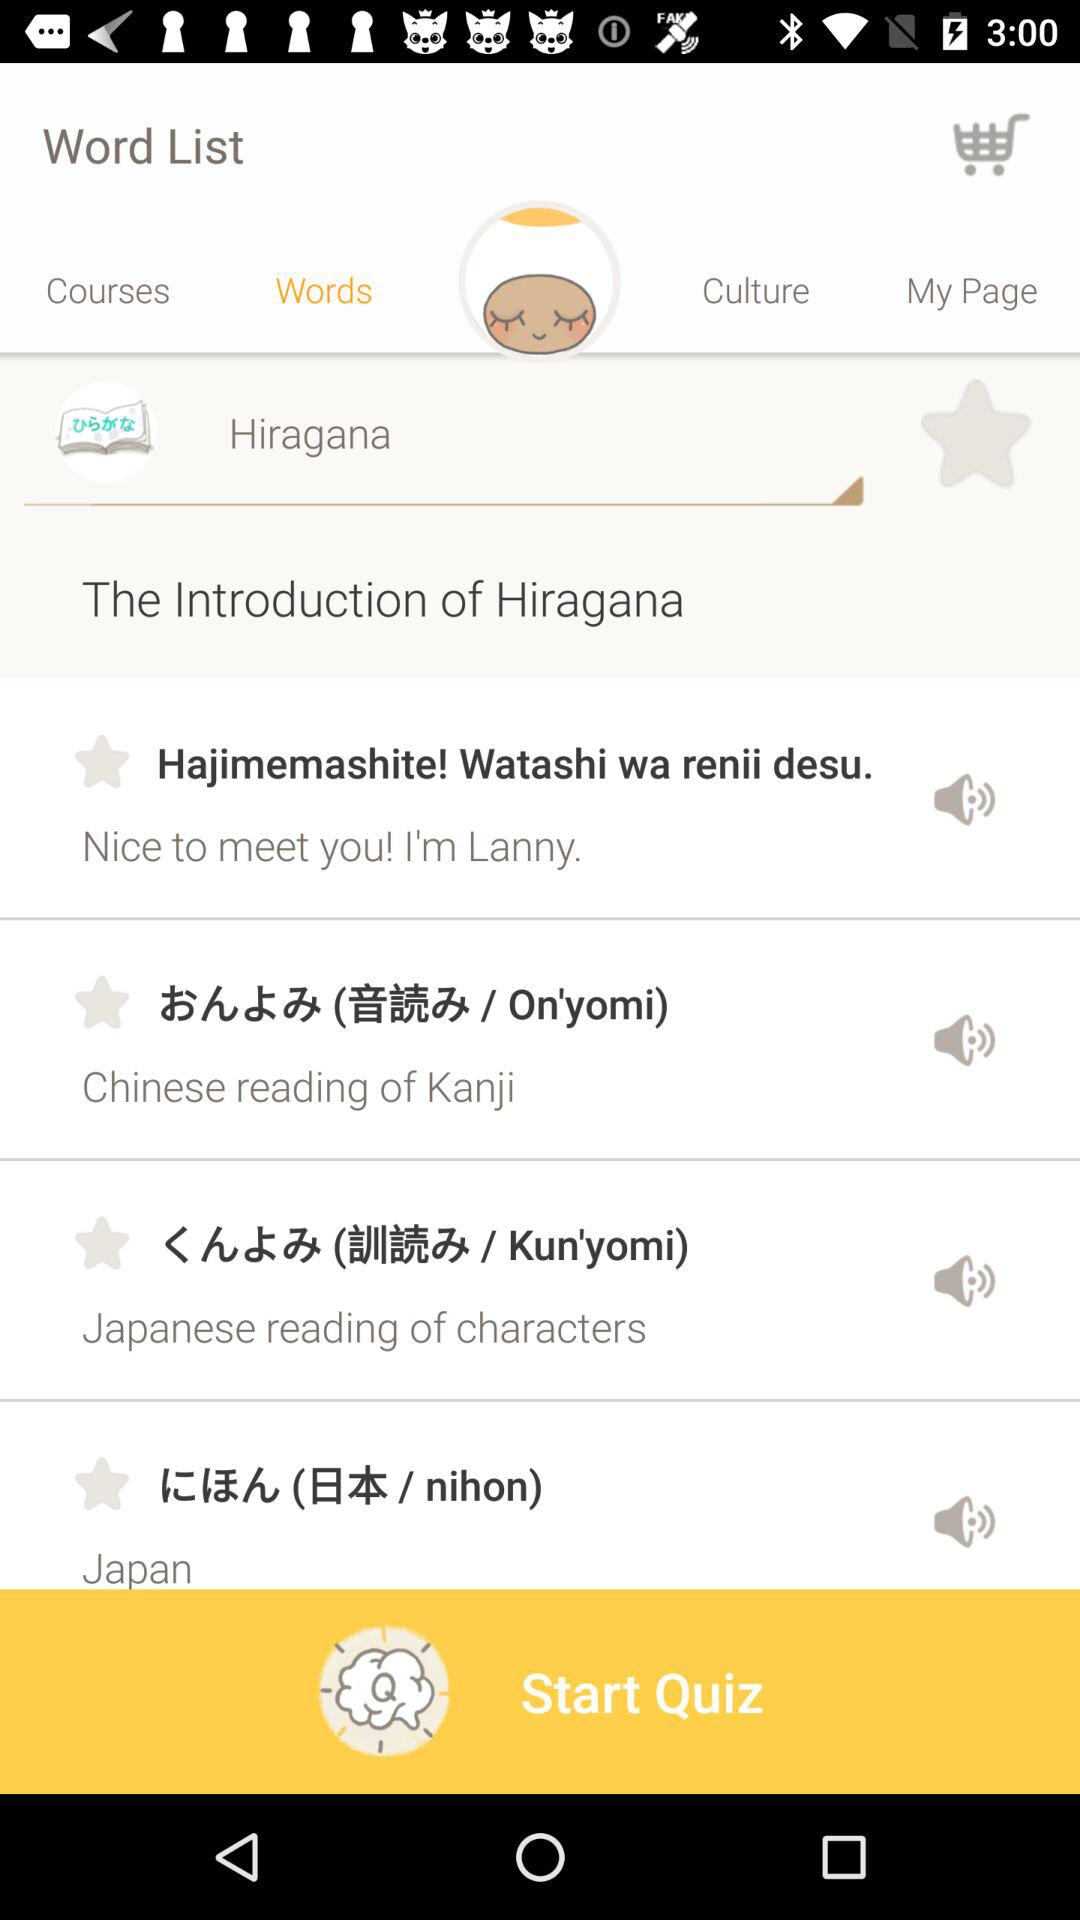Which tab is selected? The selected tab is "Words". 